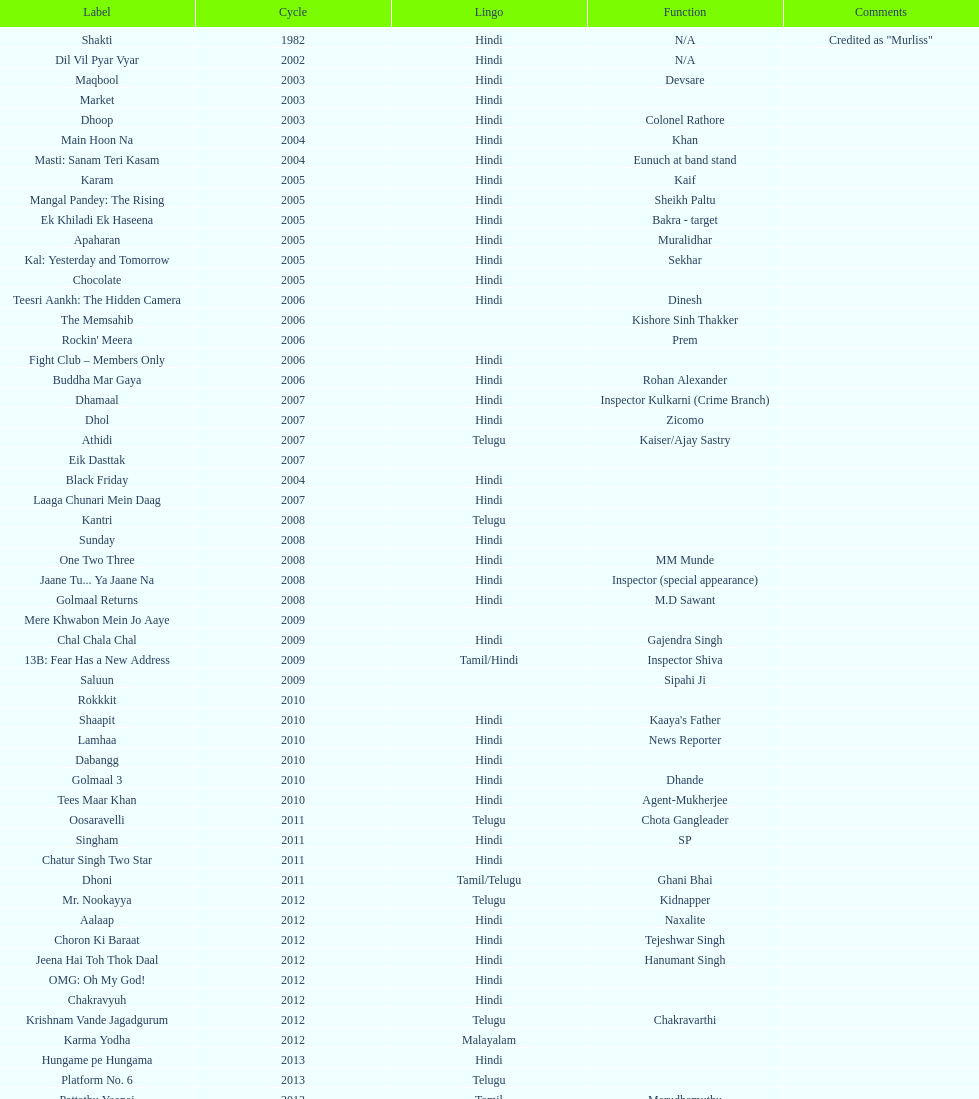How many roles has this actor had? 36. 